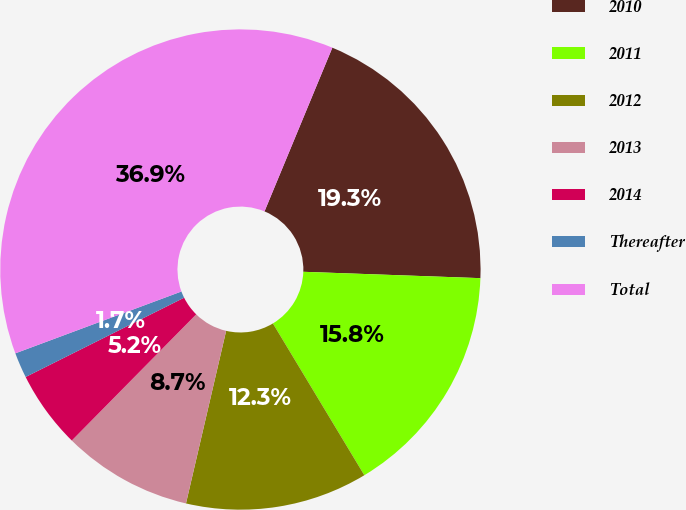Convert chart to OTSL. <chart><loc_0><loc_0><loc_500><loc_500><pie_chart><fcel>2010<fcel>2011<fcel>2012<fcel>2013<fcel>2014<fcel>Thereafter<fcel>Total<nl><fcel>19.32%<fcel>15.8%<fcel>12.27%<fcel>8.75%<fcel>5.23%<fcel>1.71%<fcel>36.93%<nl></chart> 